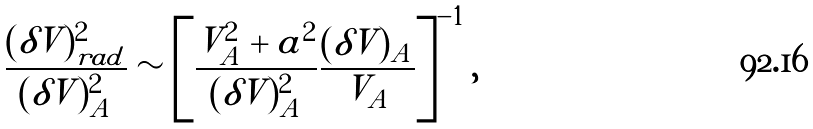<formula> <loc_0><loc_0><loc_500><loc_500>\frac { ( \delta V ) _ { r a d } ^ { 2 } } { ( \delta V ) _ { A } ^ { 2 } } \sim \left [ \frac { V _ { A } ^ { 2 } + a ^ { 2 } } { ( \delta V ) ^ { 2 } _ { A } } \frac { ( \delta V ) _ { A } } { V _ { A } } \right ] ^ { - 1 } ,</formula> 